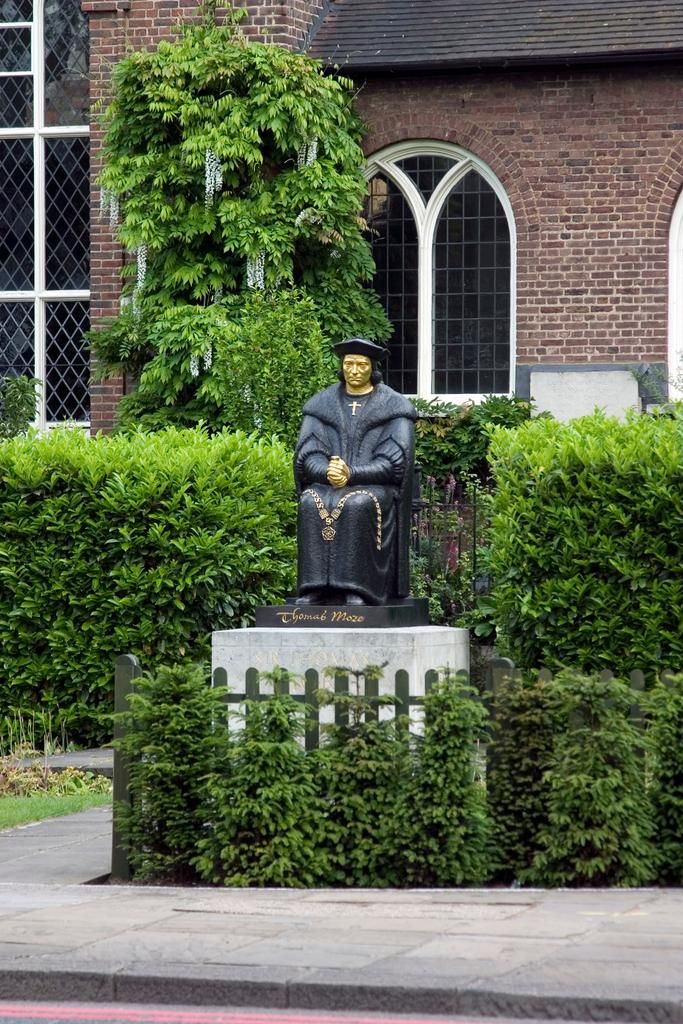What is the main subject of the image? There is a statue of a man in the image. What is surrounding the statue? There are plants and trees around the statue. What can be seen in the background of the image? There is a building in the background of the image. What type of oven is visible near the statue in the image? There is no oven present in the image; it features a statue of a man surrounded by plants and trees, with a building in the background. 